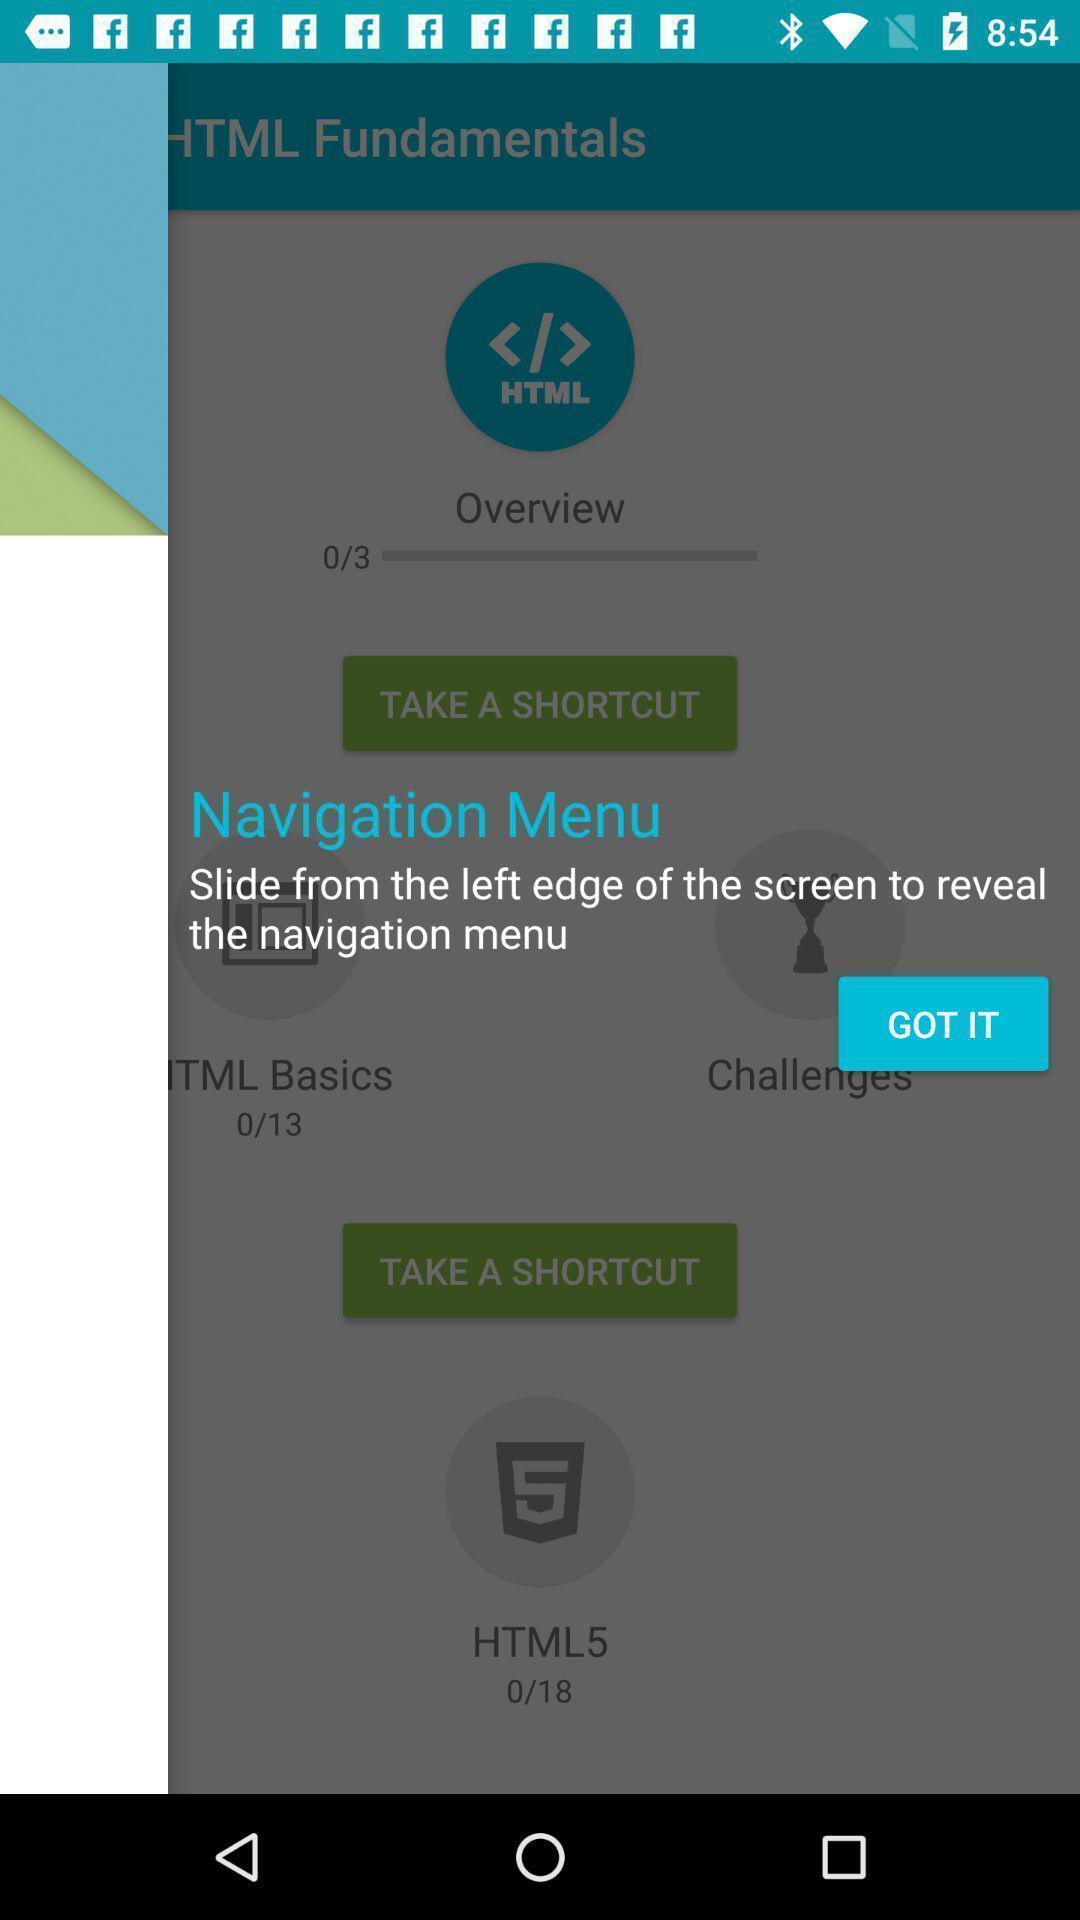Explain what's happening in this screen capture. Page showing instruction to use learning app. 